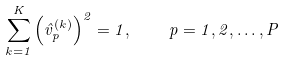Convert formula to latex. <formula><loc_0><loc_0><loc_500><loc_500>\sum _ { k = 1 } ^ { K } \left ( \hat { v } _ { p } ^ { ( k ) } \right ) ^ { 2 } = 1 , \quad p = 1 , 2 , \dots , P</formula> 